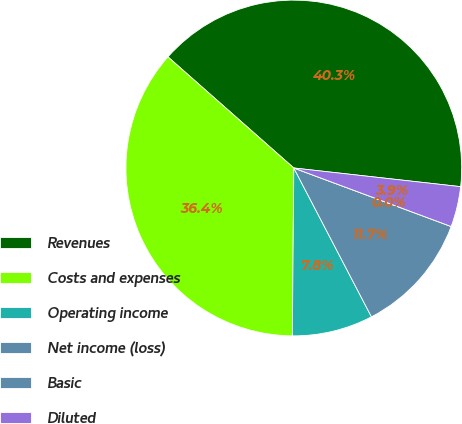<chart> <loc_0><loc_0><loc_500><loc_500><pie_chart><fcel>Revenues<fcel>Costs and expenses<fcel>Operating income<fcel>Net income (loss)<fcel>Basic<fcel>Diluted<nl><fcel>40.26%<fcel>36.37%<fcel>7.79%<fcel>11.68%<fcel>0.0%<fcel>3.89%<nl></chart> 